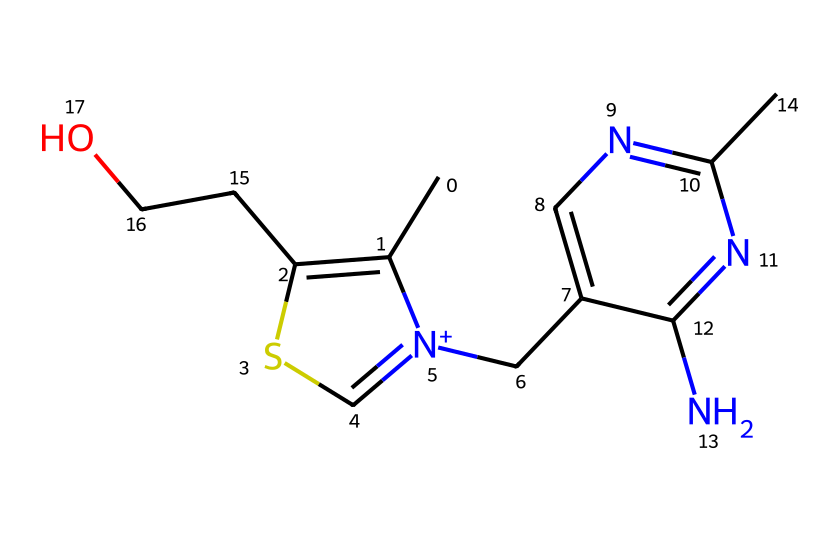What is the molecular formula of vitamin B1 (thiamine)? To determine the molecular formula, I will count the number of each type of atom in the SMILES representation: C, H, N, and O. The counts yield C12, H17, N4, O2. Therefore, the molecular formula is C12H17N4O2.
Answer: C12H17N4O2 How many nitrogen atoms are present in the structure? By inspecting the SMILES representation, I can identify and count the nitrogen atoms (N). The structure has 4 nitrogen atoms in total.
Answer: 4 What type of vitamin is vitamin B1 (thiamine)? Vitamin B1 is classified as a water-soluble vitamin. This classification can be determined based on its structure that contains polar functional groups (like hydroxyl and amine), which enhance its solubility in water.
Answer: water-soluble What functional groups can be identified in the structure? Looking at the SMILES representation, I can identify the hydroxyl group (-OH) and the amine groups (-NH and -N=) which are characteristic functional groups in vitamin B1. These functional groups play key roles in its biological functions.
Answer: hydroxyl and amine What is the structural role of the thiazole ring in vitamin B1? The thiazole ring (formed by the carbon, sulfur, and nitrogen in the structure) is crucial because it is integral to the functioning of the vitamin, particularly in its role in carbohydrate metabolism. It acts as a part of the active site for enzymatic reactions involving energy production.
Answer: metabolic function 